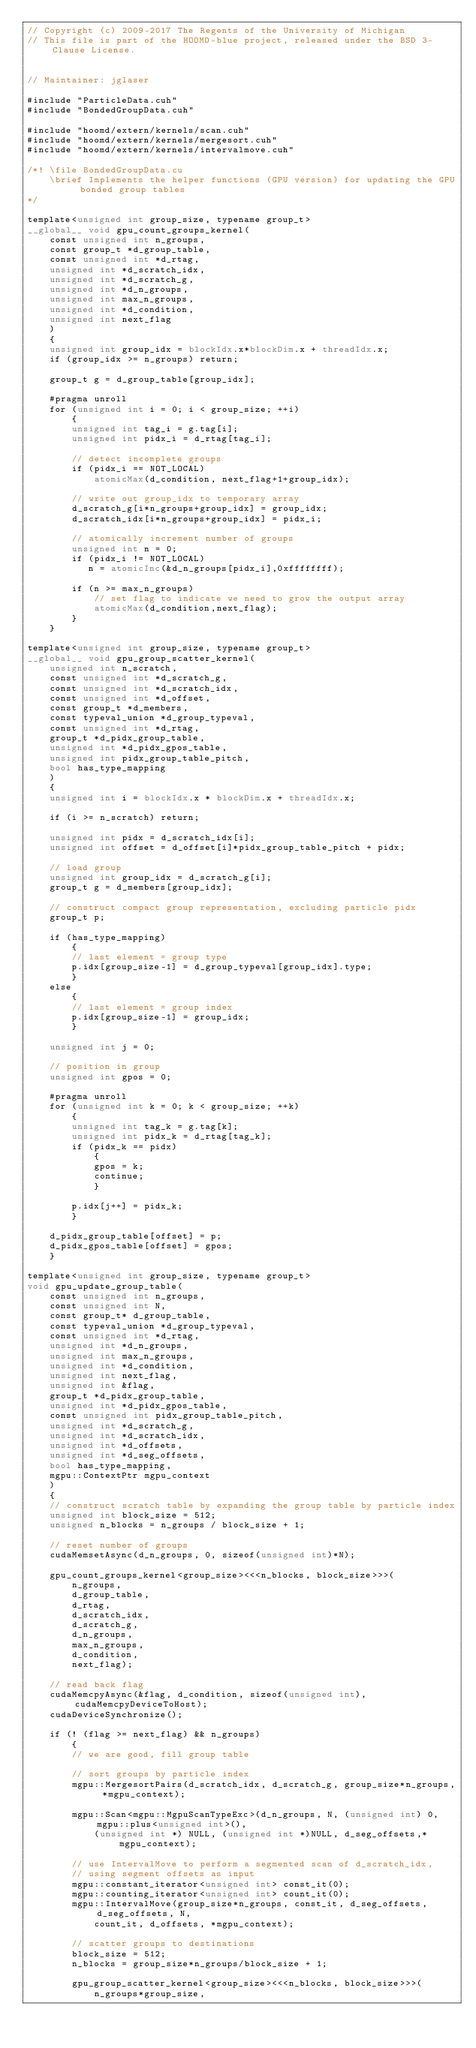<code> <loc_0><loc_0><loc_500><loc_500><_Cuda_>// Copyright (c) 2009-2017 The Regents of the University of Michigan
// This file is part of the HOOMD-blue project, released under the BSD 3-Clause License.


// Maintainer: jglaser

#include "ParticleData.cuh"
#include "BondedGroupData.cuh"

#include "hoomd/extern/kernels/scan.cuh"
#include "hoomd/extern/kernels/mergesort.cuh"
#include "hoomd/extern/kernels/intervalmove.cuh"

/*! \file BondedGroupData.cu
    \brief Implements the helper functions (GPU version) for updating the GPU bonded group tables
*/

template<unsigned int group_size, typename group_t>
__global__ void gpu_count_groups_kernel(
    const unsigned int n_groups,
    const group_t *d_group_table,
    const unsigned int *d_rtag,
    unsigned int *d_scratch_idx,
    unsigned int *d_scratch_g,
    unsigned int *d_n_groups,
    unsigned int max_n_groups,
    unsigned int *d_condition,
    unsigned int next_flag
    )
    {
    unsigned int group_idx = blockIdx.x*blockDim.x + threadIdx.x;
    if (group_idx >= n_groups) return;

    group_t g = d_group_table[group_idx];

    #pragma unroll
    for (unsigned int i = 0; i < group_size; ++i)
        {
        unsigned int tag_i = g.tag[i];
        unsigned int pidx_i = d_rtag[tag_i];

        // detect incomplete groups
        if (pidx_i == NOT_LOCAL)
            atomicMax(d_condition, next_flag+1+group_idx);

        // write out group_idx to temporary array
        d_scratch_g[i*n_groups+group_idx] = group_idx;
        d_scratch_idx[i*n_groups+group_idx] = pidx_i;

        // atomically increment number of groups
        unsigned int n = 0;
        if (pidx_i != NOT_LOCAL)
           n = atomicInc(&d_n_groups[pidx_i],0xffffffff);

        if (n >= max_n_groups)
            // set flag to indicate we need to grow the output array
            atomicMax(d_condition,next_flag);
        }
    }

template<unsigned int group_size, typename group_t>
__global__ void gpu_group_scatter_kernel(
    unsigned int n_scratch,
    const unsigned int *d_scratch_g,
    const unsigned int *d_scratch_idx,
    const unsigned int *d_offset,
    const group_t *d_members,
    const typeval_union *d_group_typeval,
    const unsigned int *d_rtag,
    group_t *d_pidx_group_table,
    unsigned int *d_pidx_gpos_table,
    unsigned int pidx_group_table_pitch,
    bool has_type_mapping
    )
    {
    unsigned int i = blockIdx.x * blockDim.x + threadIdx.x;

    if (i >= n_scratch) return;

    unsigned int pidx = d_scratch_idx[i];
    unsigned int offset = d_offset[i]*pidx_group_table_pitch + pidx;

    // load group
    unsigned int group_idx = d_scratch_g[i];
    group_t g = d_members[group_idx];

    // construct compact group representation, excluding particle pidx
    group_t p;

    if (has_type_mapping)
        {
        // last element = group type
        p.idx[group_size-1] = d_group_typeval[group_idx].type;
        }
    else
        {
        // last element = group index
        p.idx[group_size-1] = group_idx;
        }

    unsigned int j = 0;

    // position in group
    unsigned int gpos = 0;

    #pragma unroll
    for (unsigned int k = 0; k < group_size; ++k)
        {
        unsigned int tag_k = g.tag[k];
        unsigned int pidx_k = d_rtag[tag_k];
        if (pidx_k == pidx)
            {
            gpos = k;
            continue;
            }

        p.idx[j++] = pidx_k;
        }

    d_pidx_group_table[offset] = p;
    d_pidx_gpos_table[offset] = gpos;
    }

template<unsigned int group_size, typename group_t>
void gpu_update_group_table(
    const unsigned int n_groups,
    const unsigned int N,
    const group_t* d_group_table,
    const typeval_union *d_group_typeval,
    const unsigned int *d_rtag,
    unsigned int *d_n_groups,
    unsigned int max_n_groups,
    unsigned int *d_condition,
    unsigned int next_flag,
    unsigned int &flag,
    group_t *d_pidx_group_table,
    unsigned int *d_pidx_gpos_table,
    const unsigned int pidx_group_table_pitch,
    unsigned int *d_scratch_g,
    unsigned int *d_scratch_idx,
    unsigned int *d_offsets,
    unsigned int *d_seg_offsets,
    bool has_type_mapping,
    mgpu::ContextPtr mgpu_context
    )
    {
    // construct scratch table by expanding the group table by particle index
    unsigned int block_size = 512;
    unsigned n_blocks = n_groups / block_size + 1;

    // reset number of groups
    cudaMemsetAsync(d_n_groups, 0, sizeof(unsigned int)*N);

    gpu_count_groups_kernel<group_size><<<n_blocks, block_size>>>(
        n_groups,
        d_group_table,
        d_rtag,
        d_scratch_idx,
        d_scratch_g,
        d_n_groups,
        max_n_groups,
        d_condition,
        next_flag);

    // read back flag
    cudaMemcpyAsync(&flag, d_condition, sizeof(unsigned int), cudaMemcpyDeviceToHost);
    cudaDeviceSynchronize();

    if (! (flag >= next_flag) && n_groups)
        {
        // we are good, fill group table

        // sort groups by particle index
        mgpu::MergesortPairs(d_scratch_idx, d_scratch_g, group_size*n_groups, *mgpu_context);

        mgpu::Scan<mgpu::MgpuScanTypeExc>(d_n_groups, N, (unsigned int) 0, mgpu::plus<unsigned int>(),
            (unsigned int *) NULL, (unsigned int *)NULL, d_seg_offsets,*mgpu_context);

        // use IntervalMove to perform a segmented scan of d_scratch_idx,
        // using segment offsets as input
        mgpu::constant_iterator<unsigned int> const_it(0);
        mgpu::counting_iterator<unsigned int> count_it(0);
        mgpu::IntervalMove(group_size*n_groups, const_it, d_seg_offsets, d_seg_offsets, N,
            count_it, d_offsets, *mgpu_context);

        // scatter groups to destinations
        block_size = 512;
        n_blocks = group_size*n_groups/block_size + 1;

        gpu_group_scatter_kernel<group_size><<<n_blocks, block_size>>>(
            n_groups*group_size,</code> 